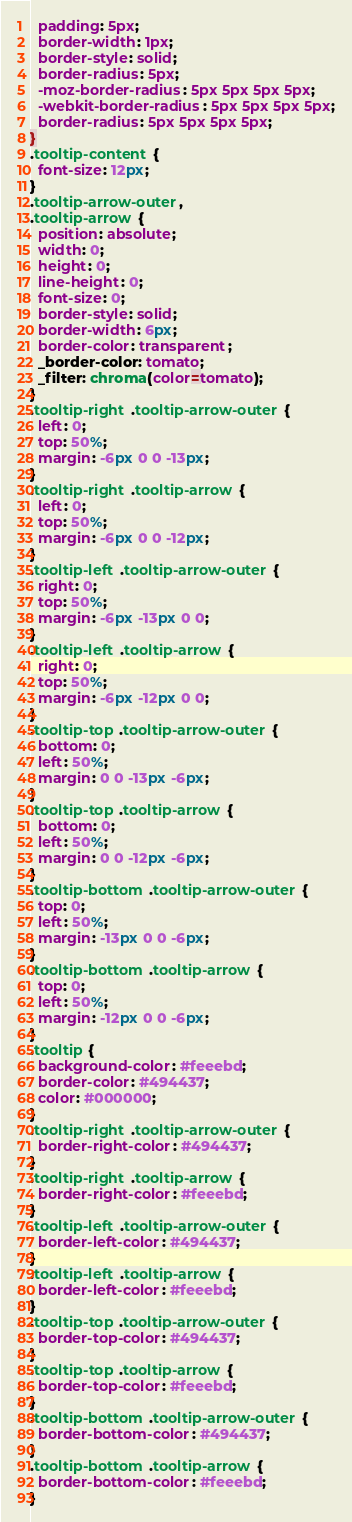Convert code to text. <code><loc_0><loc_0><loc_500><loc_500><_CSS_>  padding: 5px;
  border-width: 1px;
  border-style: solid;
  border-radius: 5px;
  -moz-border-radius: 5px 5px 5px 5px;
  -webkit-border-radius: 5px 5px 5px 5px;
  border-radius: 5px 5px 5px 5px;
}
.tooltip-content {
  font-size: 12px;
}
.tooltip-arrow-outer,
.tooltip-arrow {
  position: absolute;
  width: 0;
  height: 0;
  line-height: 0;
  font-size: 0;
  border-style: solid;
  border-width: 6px;
  border-color: transparent;
  _border-color: tomato;
  _filter: chroma(color=tomato);
}
.tooltip-right .tooltip-arrow-outer {
  left: 0;
  top: 50%;
  margin: -6px 0 0 -13px;
}
.tooltip-right .tooltip-arrow {
  left: 0;
  top: 50%;
  margin: -6px 0 0 -12px;
}
.tooltip-left .tooltip-arrow-outer {
  right: 0;
  top: 50%;
  margin: -6px -13px 0 0;
}
.tooltip-left .tooltip-arrow {
  right: 0;
  top: 50%;
  margin: -6px -12px 0 0;
}
.tooltip-top .tooltip-arrow-outer {
  bottom: 0;
  left: 50%;
  margin: 0 0 -13px -6px;
}
.tooltip-top .tooltip-arrow {
  bottom: 0;
  left: 50%;
  margin: 0 0 -12px -6px;
}
.tooltip-bottom .tooltip-arrow-outer {
  top: 0;
  left: 50%;
  margin: -13px 0 0 -6px;
}
.tooltip-bottom .tooltip-arrow {
  top: 0;
  left: 50%;
  margin: -12px 0 0 -6px;
}
.tooltip {
  background-color: #feeebd;
  border-color: #494437;
  color: #000000;
}
.tooltip-right .tooltip-arrow-outer {
  border-right-color: #494437;
}
.tooltip-right .tooltip-arrow {
  border-right-color: #feeebd;
}
.tooltip-left .tooltip-arrow-outer {
  border-left-color: #494437;
}
.tooltip-left .tooltip-arrow {
  border-left-color: #feeebd;
}
.tooltip-top .tooltip-arrow-outer {
  border-top-color: #494437;
}
.tooltip-top .tooltip-arrow {
  border-top-color: #feeebd;
}
.tooltip-bottom .tooltip-arrow-outer {
  border-bottom-color: #494437;
}
.tooltip-bottom .tooltip-arrow {
  border-bottom-color: #feeebd;
}
</code> 